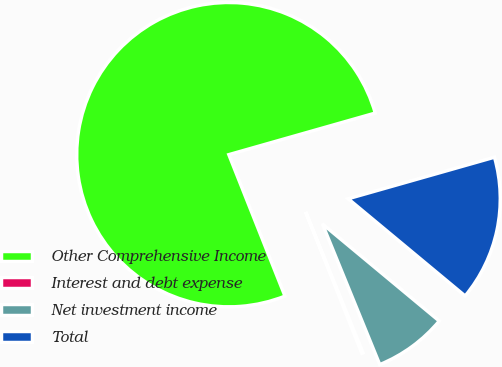Convert chart. <chart><loc_0><loc_0><loc_500><loc_500><pie_chart><fcel>Other Comprehensive Income<fcel>Interest and debt expense<fcel>Net investment income<fcel>Total<nl><fcel>76.61%<fcel>0.15%<fcel>7.8%<fcel>15.44%<nl></chart> 